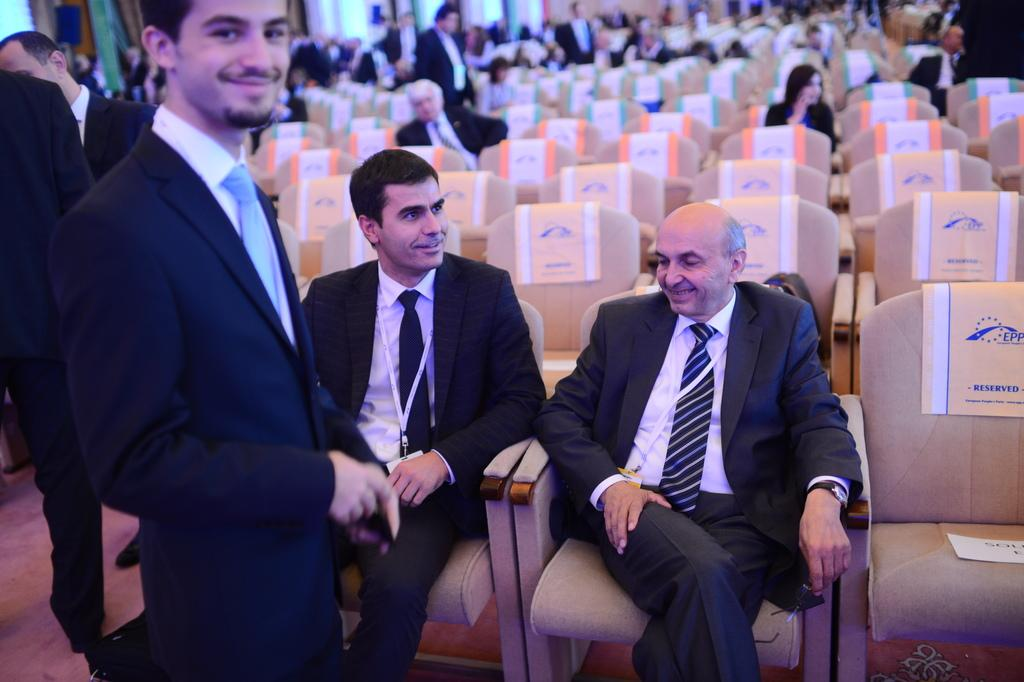What are the people in the image doing? There is a group of people sitting on chairs, and there are people standing in the image. Can you describe the setting in which the people are located? There is a wall visible in the image, which suggests an indoor or enclosed space. What type of meat is being cooked on the heat source in the image? There is no heat source or meat present in the image; it features a group of people sitting on chairs and standing near a wall. 